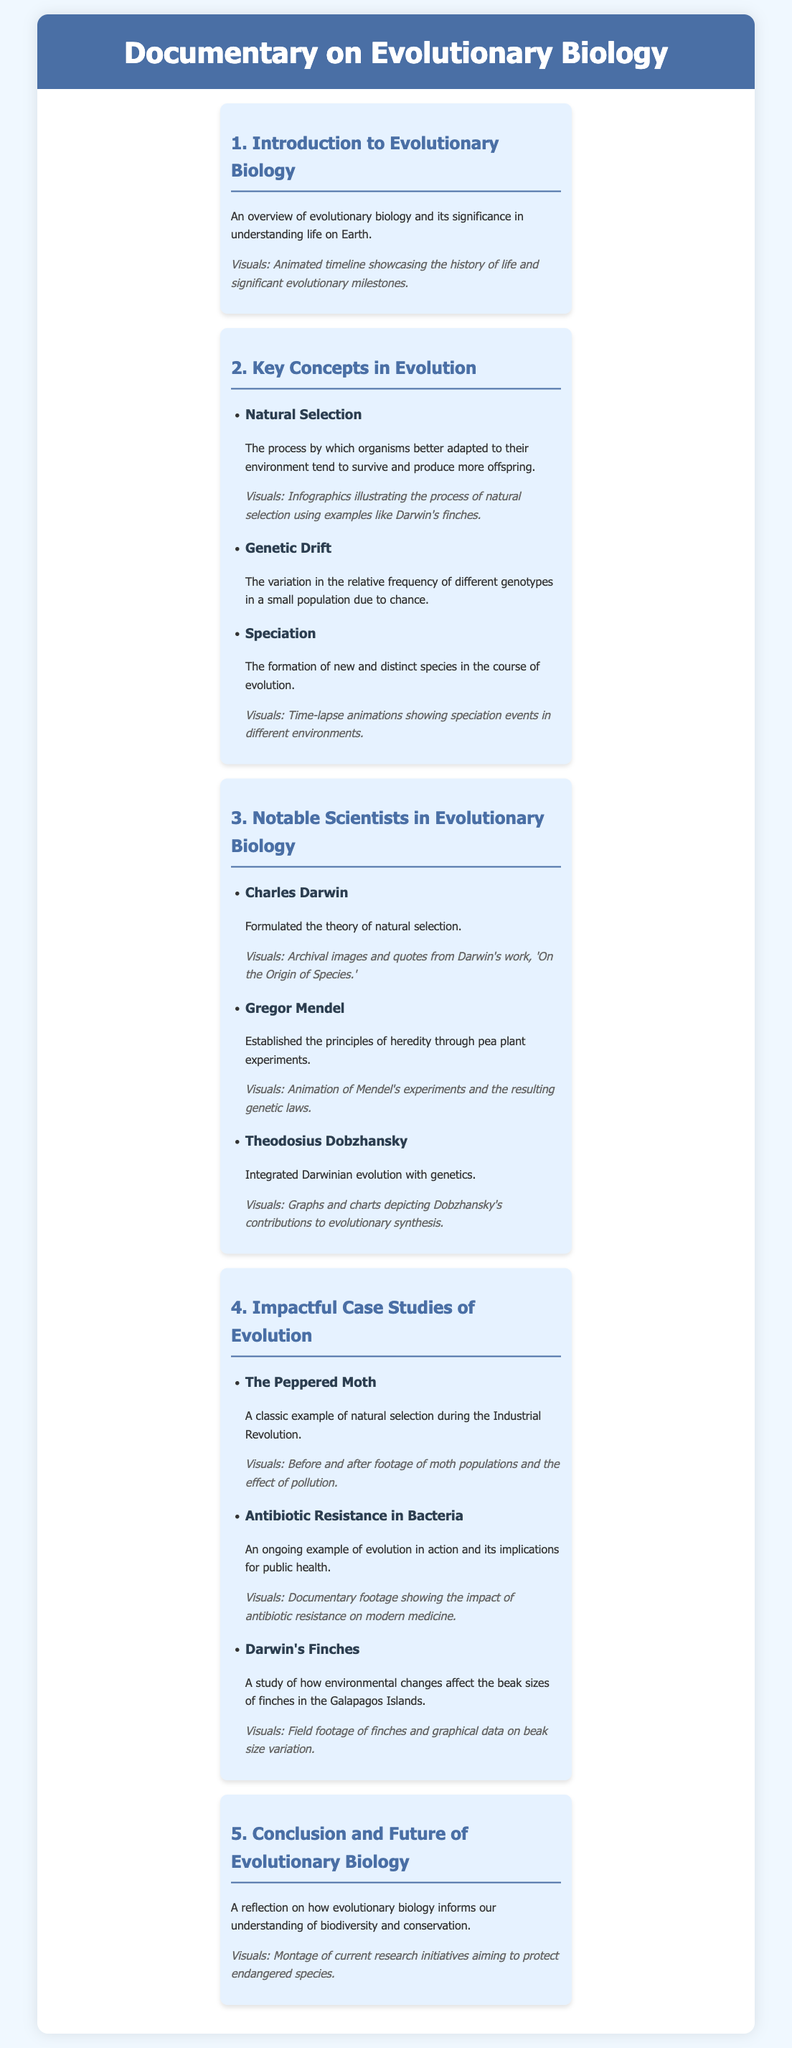What is the title of the documentary? The title is provided in the header and summarizes the content of the document.
Answer: Documentary on Evolutionary Biology Who formulated the theory of natural selection? The document mentions notable scientists, including their contributions to evolutionary biology.
Answer: Charles Darwin What visual element is included for genetic drift? The visuals should enhance the understanding of key concepts discussed in the document.
Answer: None specified What case study exemplifies the impact of the Industrial Revolution? The case studies illustrate real-world examples of evolutionary concepts in action.
Answer: The Peppered Moth How does the documentary conclude? The conclusion reflects on the overarching theme of the documentary based on the final section.
Answer: Understanding of biodiversity and conservation What two elements are present in the visuals for Darwin's finches? The visuals accompany the content to make it engaging and informative, so they should include relevant aspects of that case study.
Answer: Field footage and graphical data What important concept does speciation relate to? The document outlines sections that define specific evolutionary processes, including speciation.
Answer: Formation of new species How many notable scientists are mentioned in the document? The document lists various scientists along with their contributions to evolutionary biology.
Answer: Three What does the section "Key Concepts in Evolution" include? The structure of the document categorizes the content into various key sections relevant to the theme.
Answer: Natural Selection, Genetic Drift, Speciation 